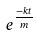<formula> <loc_0><loc_0><loc_500><loc_500>e ^ { \frac { - k t } { m } }</formula> 